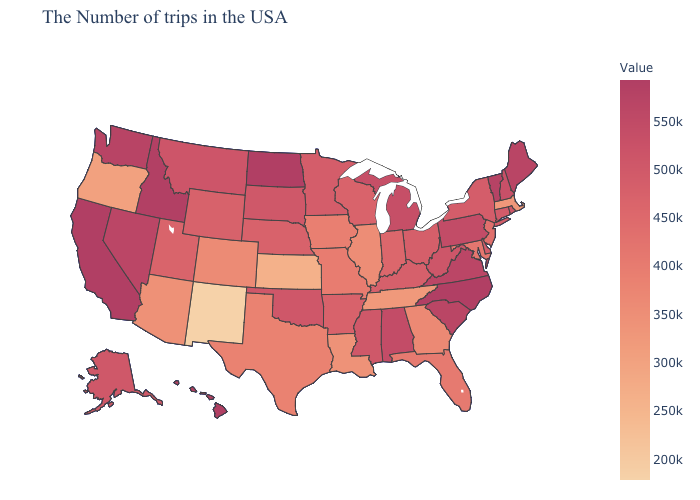Does Minnesota have the highest value in the MidWest?
Quick response, please. No. Which states have the highest value in the USA?
Keep it brief. North Carolina, North Dakota, California, Hawaii. Which states hav the highest value in the MidWest?
Short answer required. North Dakota. Which states hav the highest value in the West?
Answer briefly. California, Hawaii. Which states have the highest value in the USA?
Concise answer only. North Carolina, North Dakota, California, Hawaii. Which states have the highest value in the USA?
Write a very short answer. North Carolina, North Dakota, California, Hawaii. Does South Carolina have the highest value in the USA?
Quick response, please. No. Does North Carolina have the highest value in the South?
Quick response, please. Yes. Which states have the highest value in the USA?
Short answer required. North Carolina, North Dakota, California, Hawaii. 